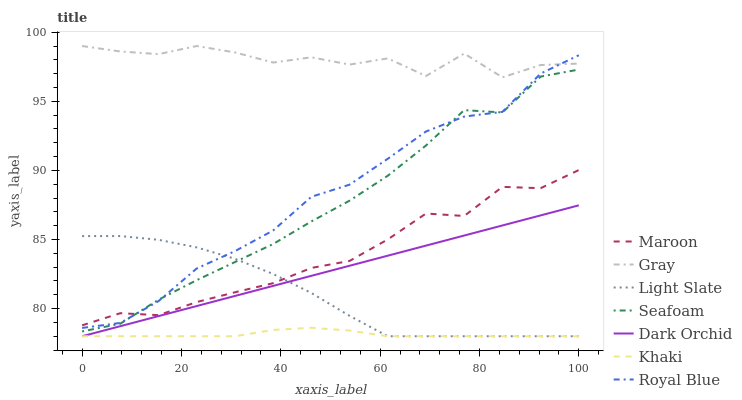Does Khaki have the minimum area under the curve?
Answer yes or no. Yes. Does Gray have the maximum area under the curve?
Answer yes or no. Yes. Does Light Slate have the minimum area under the curve?
Answer yes or no. No. Does Light Slate have the maximum area under the curve?
Answer yes or no. No. Is Dark Orchid the smoothest?
Answer yes or no. Yes. Is Gray the roughest?
Answer yes or no. Yes. Is Khaki the smoothest?
Answer yes or no. No. Is Khaki the roughest?
Answer yes or no. No. Does Khaki have the lowest value?
Answer yes or no. Yes. Does Seafoam have the lowest value?
Answer yes or no. No. Does Gray have the highest value?
Answer yes or no. Yes. Does Light Slate have the highest value?
Answer yes or no. No. Is Khaki less than Seafoam?
Answer yes or no. Yes. Is Gray greater than Seafoam?
Answer yes or no. Yes. Does Maroon intersect Royal Blue?
Answer yes or no. Yes. Is Maroon less than Royal Blue?
Answer yes or no. No. Is Maroon greater than Royal Blue?
Answer yes or no. No. Does Khaki intersect Seafoam?
Answer yes or no. No. 